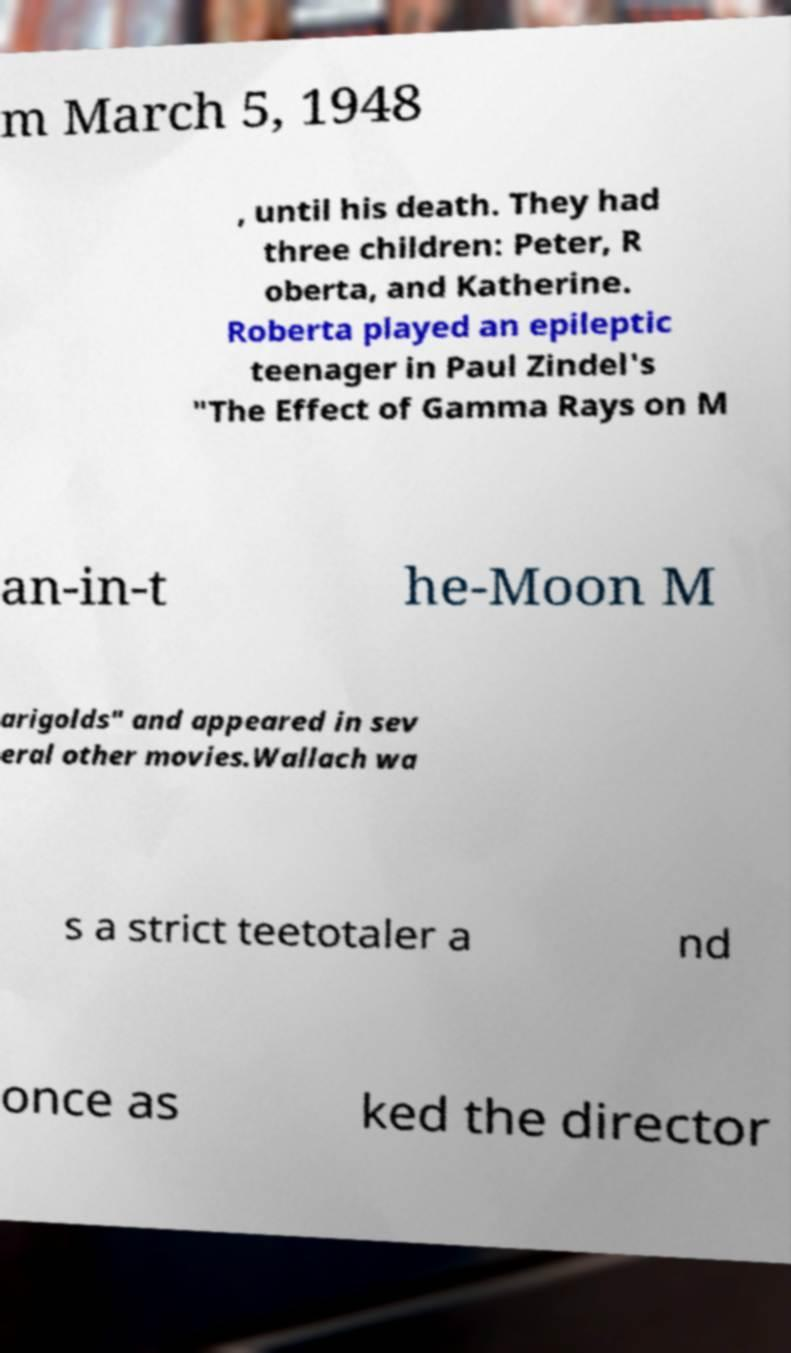I need the written content from this picture converted into text. Can you do that? m March 5, 1948 , until his death. They had three children: Peter, R oberta, and Katherine. Roberta played an epileptic teenager in Paul Zindel's "The Effect of Gamma Rays on M an-in-t he-Moon M arigolds" and appeared in sev eral other movies.Wallach wa s a strict teetotaler a nd once as ked the director 